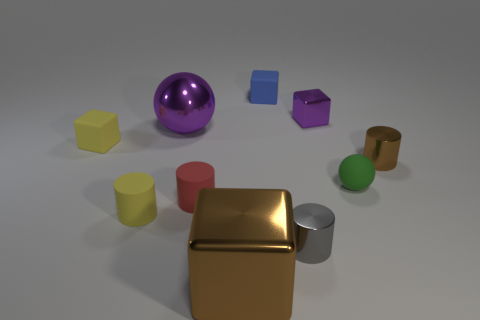Subtract 1 cubes. How many cubes are left? 3 Subtract all blue rubber cubes. How many cubes are left? 3 Subtract all brown blocks. How many blocks are left? 3 Subtract all cyan cylinders. Subtract all green spheres. How many cylinders are left? 4 Subtract all cylinders. How many objects are left? 6 Subtract all blue cubes. Subtract all large brown shiny things. How many objects are left? 8 Add 4 metal cubes. How many metal cubes are left? 6 Add 3 large blue metal cubes. How many large blue metal cubes exist? 3 Subtract 1 brown cubes. How many objects are left? 9 